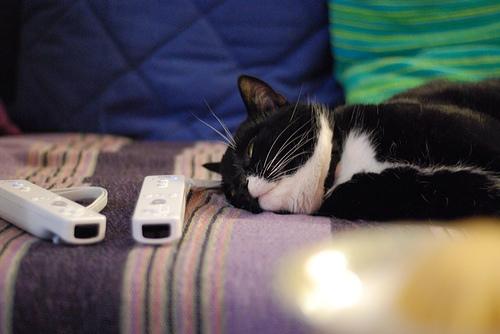How many Wii remotes are there?
Short answer required. 2. What is this cat doing?
Short answer required. Sleeping. What's the color of the tip of the controls?
Short answer required. Black. Is the cat sleeping?
Keep it brief. Yes. Is the cat licking the plastic?
Answer briefly. No. 